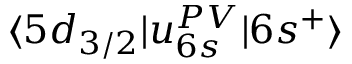<formula> <loc_0><loc_0><loc_500><loc_500>\langle 5 d _ { 3 / 2 } | u _ { 6 s } ^ { P V } | 6 s ^ { + } \rangle</formula> 